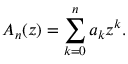<formula> <loc_0><loc_0><loc_500><loc_500>A _ { n } ( z ) = \sum _ { k = 0 } ^ { n } a _ { k } z ^ { k } .</formula> 